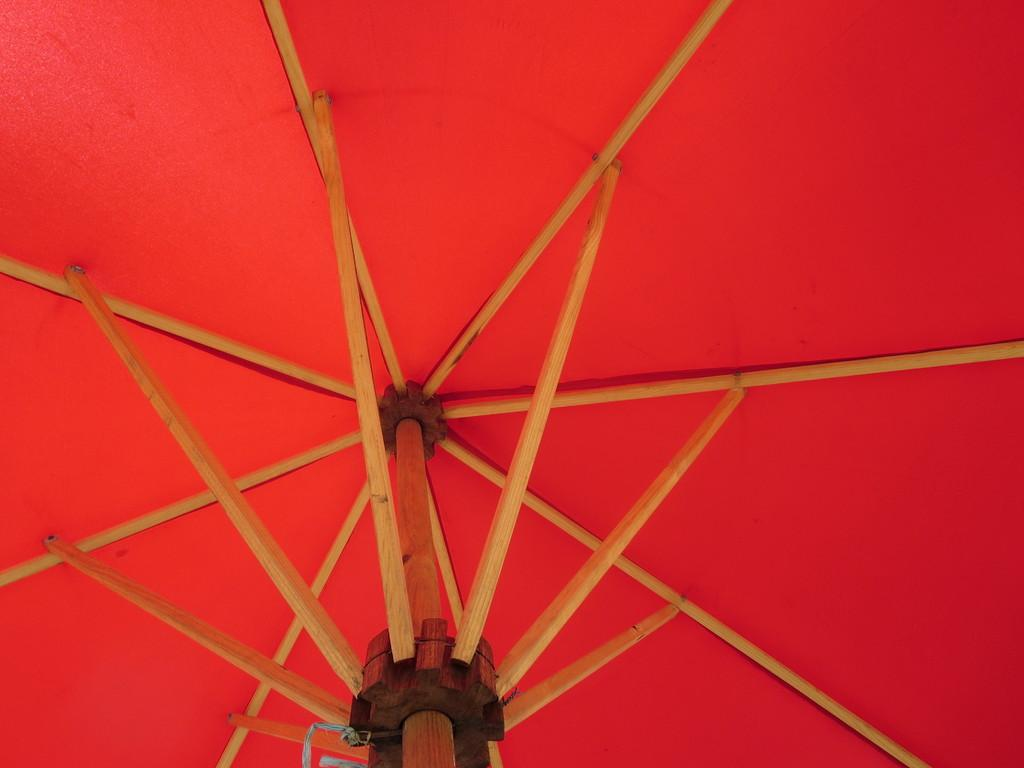What object is present in the image that can provide shelter from the rain? There is an umbrella in the image. What can be observed about the background of the wooden sticks? The background of the wooden sticks is in red color. What type of quilt is being used to cover the range in the image? There is no quilt or range present in the image; it only features an umbrella and wooden sticks with a red background. 